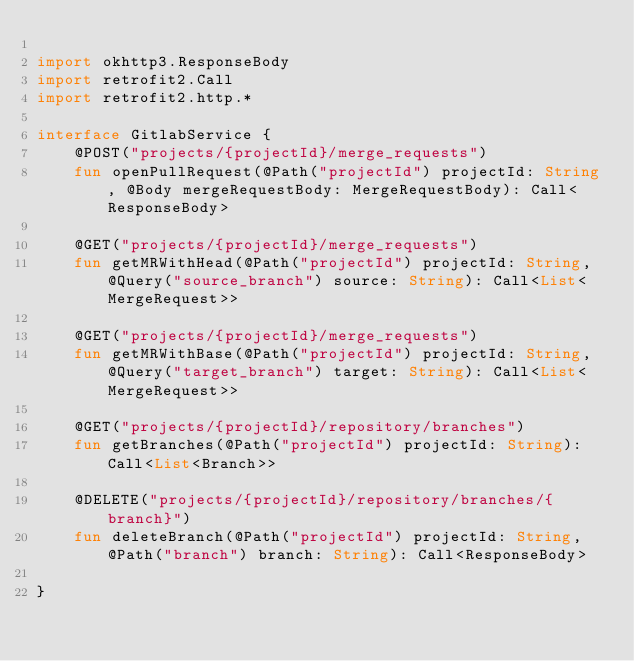Convert code to text. <code><loc_0><loc_0><loc_500><loc_500><_Kotlin_>
import okhttp3.ResponseBody
import retrofit2.Call
import retrofit2.http.*

interface GitlabService {
    @POST("projects/{projectId}/merge_requests")
    fun openPullRequest(@Path("projectId") projectId: String, @Body mergeRequestBody: MergeRequestBody): Call<ResponseBody>

    @GET("projects/{projectId}/merge_requests")
    fun getMRWithHead(@Path("projectId") projectId: String, @Query("source_branch") source: String): Call<List<MergeRequest>>

    @GET("projects/{projectId}/merge_requests")
    fun getMRWithBase(@Path("projectId") projectId: String, @Query("target_branch") target: String): Call<List<MergeRequest>>

    @GET("projects/{projectId}/repository/branches")
    fun getBranches(@Path("projectId") projectId: String): Call<List<Branch>>

    @DELETE("projects/{projectId}/repository/branches/{branch}")
    fun deleteBranch(@Path("projectId") projectId: String, @Path("branch") branch: String): Call<ResponseBody>

}
</code> 